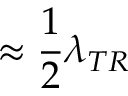<formula> <loc_0><loc_0><loc_500><loc_500>\approx \frac { 1 } { 2 } \lambda _ { T R }</formula> 